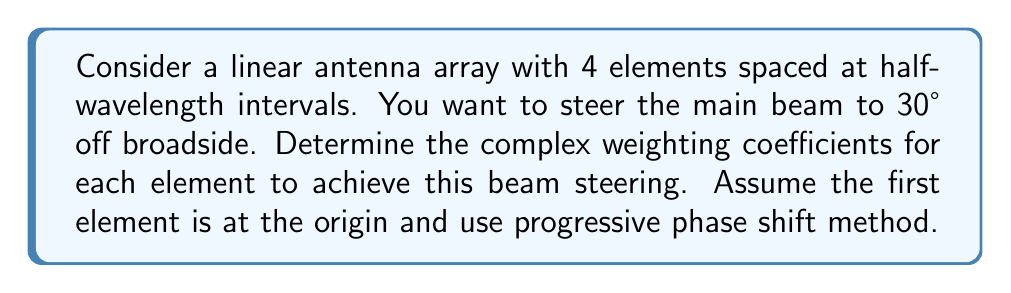Provide a solution to this math problem. To solve this problem, we'll follow these steps:

1) The phase shift between adjacent elements for beam steering is given by:
   $$\Delta\phi = -kd\sin\theta$$
   where $k = \frac{2\pi}{\lambda}$ is the wave number, $d$ is the element spacing, and $\theta$ is the desired beam angle.

2) Given:
   - Number of elements: 4
   - Element spacing: $d = \frac{\lambda}{2}$
   - Desired beam angle: $\theta = 30°$

3) Calculate the phase shift:
   $$\Delta\phi = -\frac{2\pi}{\lambda} \cdot \frac{\lambda}{2} \cdot \sin(30°)$$
   $$\Delta\phi = -\pi \cdot \frac{1}{2} = -\frac{\pi}{2} = -90°$$

4) The complex weighting coefficients will have unit magnitude and progressive phase:
   - Element 1: $w_1 = 1 \angle 0° = 1$
   - Element 2: $w_2 = 1 \angle (-90°) = -j$
   - Element 3: $w_3 = 1 \angle (-180°) = -1$
   - Element 4: $w_4 = 1 \angle (-270°) = j$

5) Express these in complex exponential form:
   $$w_n = e^{-j(n-1)\frac{\pi}{2}}$$ for $n = 1, 2, 3, 4$
Answer: $w_n = e^{-j(n-1)\frac{\pi}{2}}$ for $n = 1, 2, 3, 4$ 